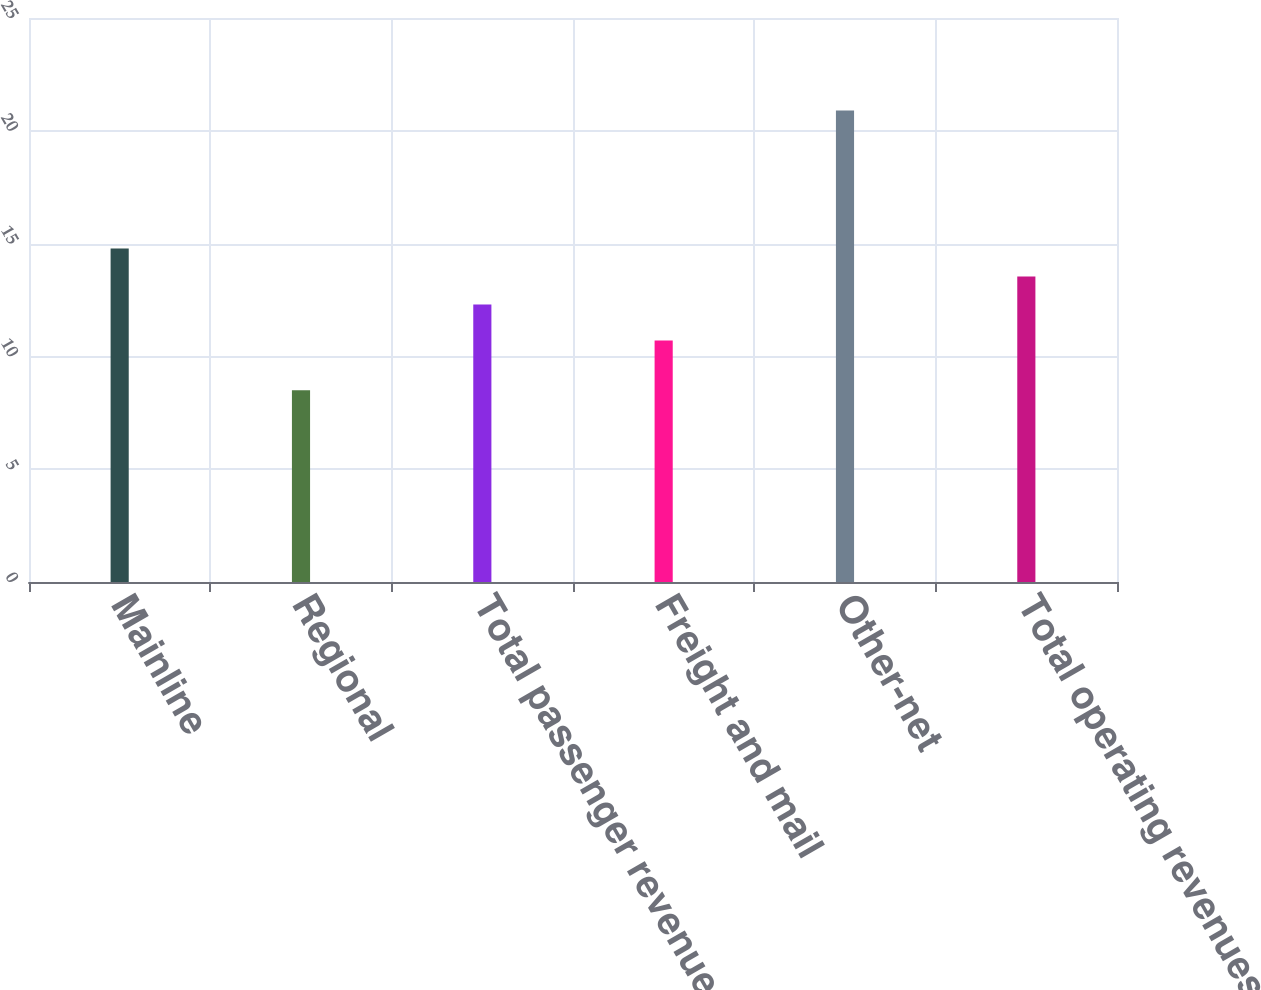<chart> <loc_0><loc_0><loc_500><loc_500><bar_chart><fcel>Mainline<fcel>Regional<fcel>Total passenger revenue<fcel>Freight and mail<fcel>Other-net<fcel>Total operating revenues<nl><fcel>14.78<fcel>8.5<fcel>12.3<fcel>10.7<fcel>20.9<fcel>13.54<nl></chart> 